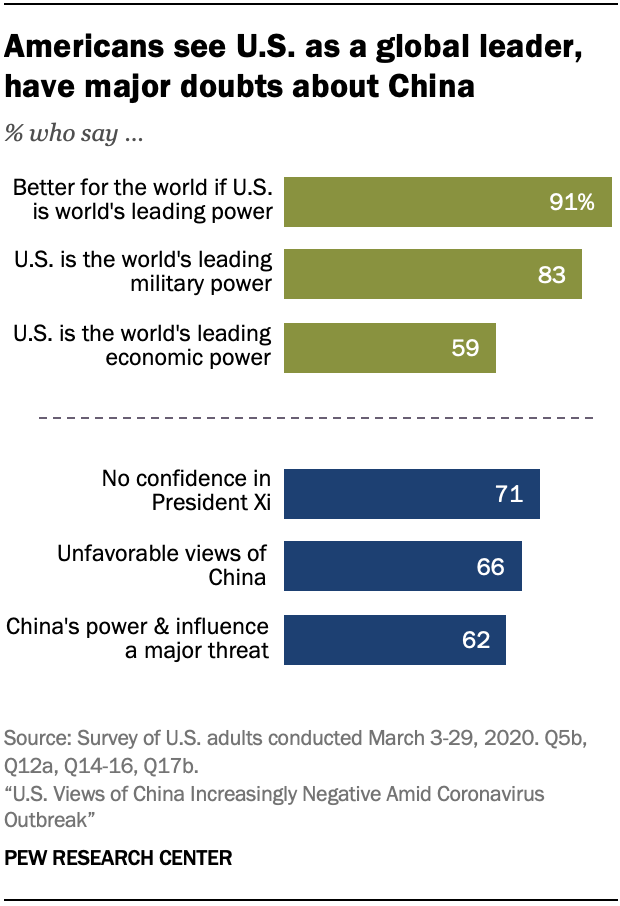Specify some key components in this picture. The product of the median values of blue and green bars is 5478. The first green bar from the top has a percentage value of 91. 